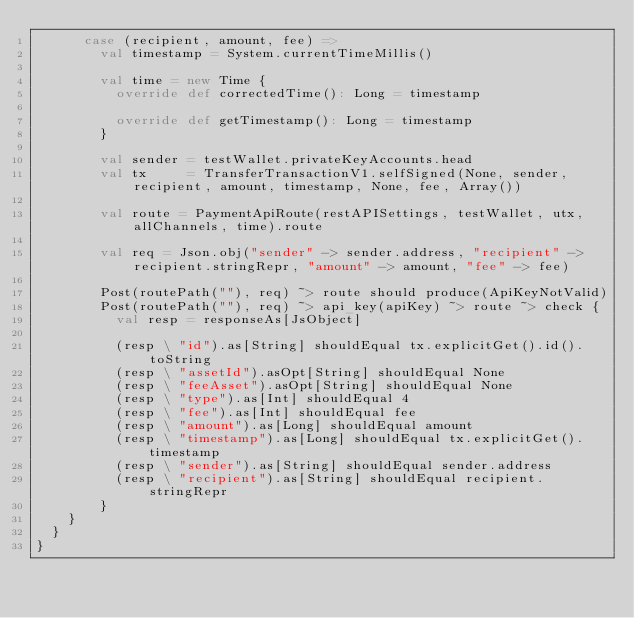<code> <loc_0><loc_0><loc_500><loc_500><_Scala_>      case (recipient, amount, fee) =>
        val timestamp = System.currentTimeMillis()

        val time = new Time {
          override def correctedTime(): Long = timestamp

          override def getTimestamp(): Long = timestamp
        }

        val sender = testWallet.privateKeyAccounts.head
        val tx     = TransferTransactionV1.selfSigned(None, sender, recipient, amount, timestamp, None, fee, Array())

        val route = PaymentApiRoute(restAPISettings, testWallet, utx, allChannels, time).route

        val req = Json.obj("sender" -> sender.address, "recipient" -> recipient.stringRepr, "amount" -> amount, "fee" -> fee)

        Post(routePath(""), req) ~> route should produce(ApiKeyNotValid)
        Post(routePath(""), req) ~> api_key(apiKey) ~> route ~> check {
          val resp = responseAs[JsObject]

          (resp \ "id").as[String] shouldEqual tx.explicitGet().id().toString
          (resp \ "assetId").asOpt[String] shouldEqual None
          (resp \ "feeAsset").asOpt[String] shouldEqual None
          (resp \ "type").as[Int] shouldEqual 4
          (resp \ "fee").as[Int] shouldEqual fee
          (resp \ "amount").as[Long] shouldEqual amount
          (resp \ "timestamp").as[Long] shouldEqual tx.explicitGet().timestamp
          (resp \ "sender").as[String] shouldEqual sender.address
          (resp \ "recipient").as[String] shouldEqual recipient.stringRepr
        }
    }
  }
}
</code> 